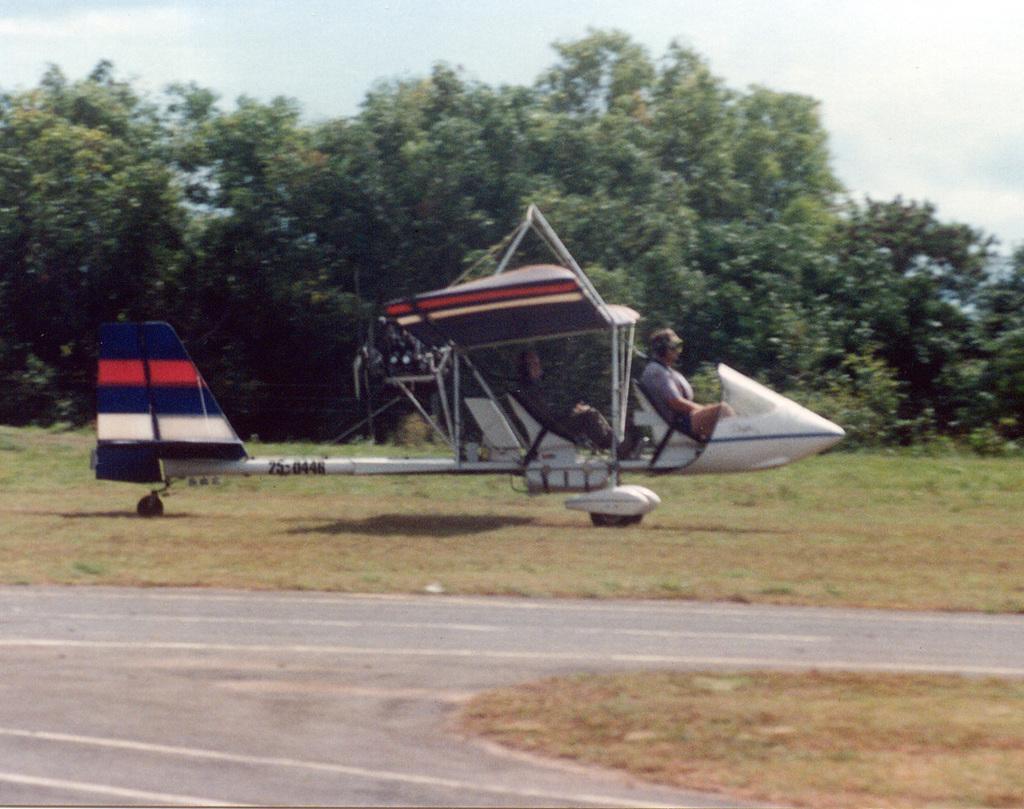In one or two sentences, can you explain what this image depicts? In this image we can see people sitting in the aircraft and there is a road. In the background there are trees and sky. 